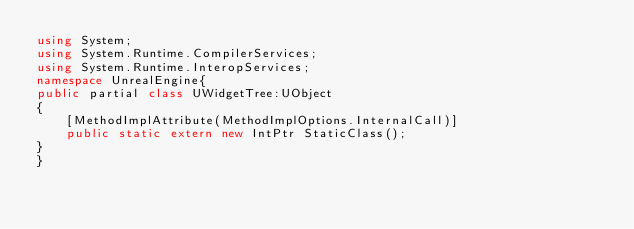<code> <loc_0><loc_0><loc_500><loc_500><_C#_>using System;
using System.Runtime.CompilerServices;
using System.Runtime.InteropServices;
namespace UnrealEngine{
public partial class UWidgetTree:UObject 
{
	[MethodImplAttribute(MethodImplOptions.InternalCall)]
	public static extern new IntPtr StaticClass();
}
}
</code> 